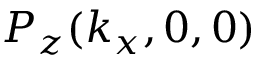Convert formula to latex. <formula><loc_0><loc_0><loc_500><loc_500>P _ { z } ( k _ { x } , 0 , 0 )</formula> 